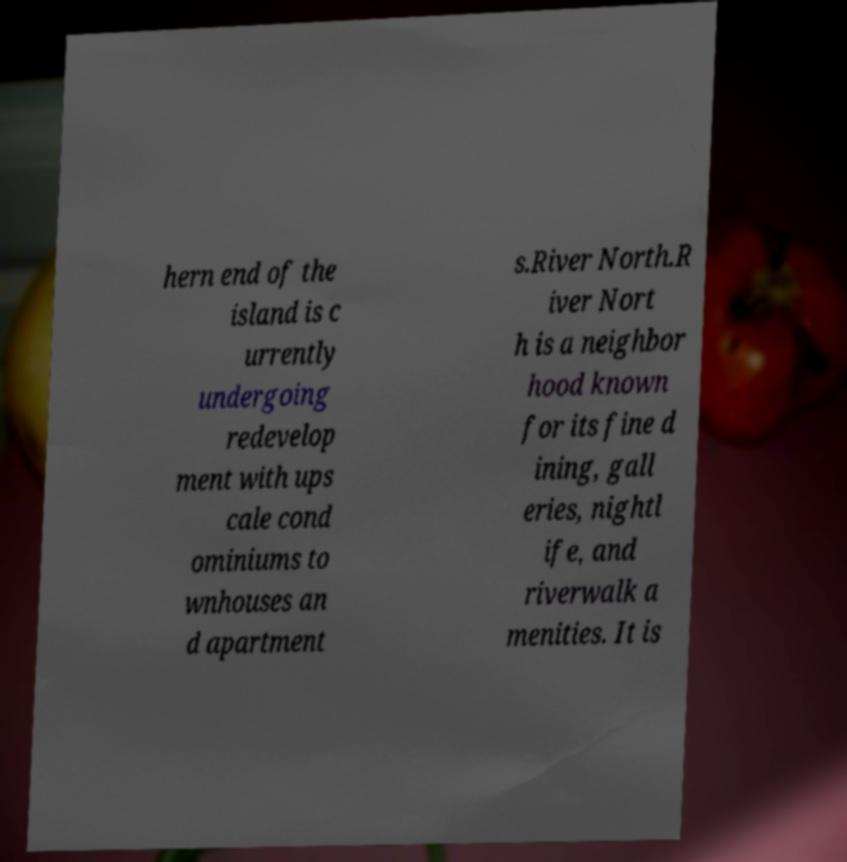Can you read and provide the text displayed in the image?This photo seems to have some interesting text. Can you extract and type it out for me? hern end of the island is c urrently undergoing redevelop ment with ups cale cond ominiums to wnhouses an d apartment s.River North.R iver Nort h is a neighbor hood known for its fine d ining, gall eries, nightl ife, and riverwalk a menities. It is 